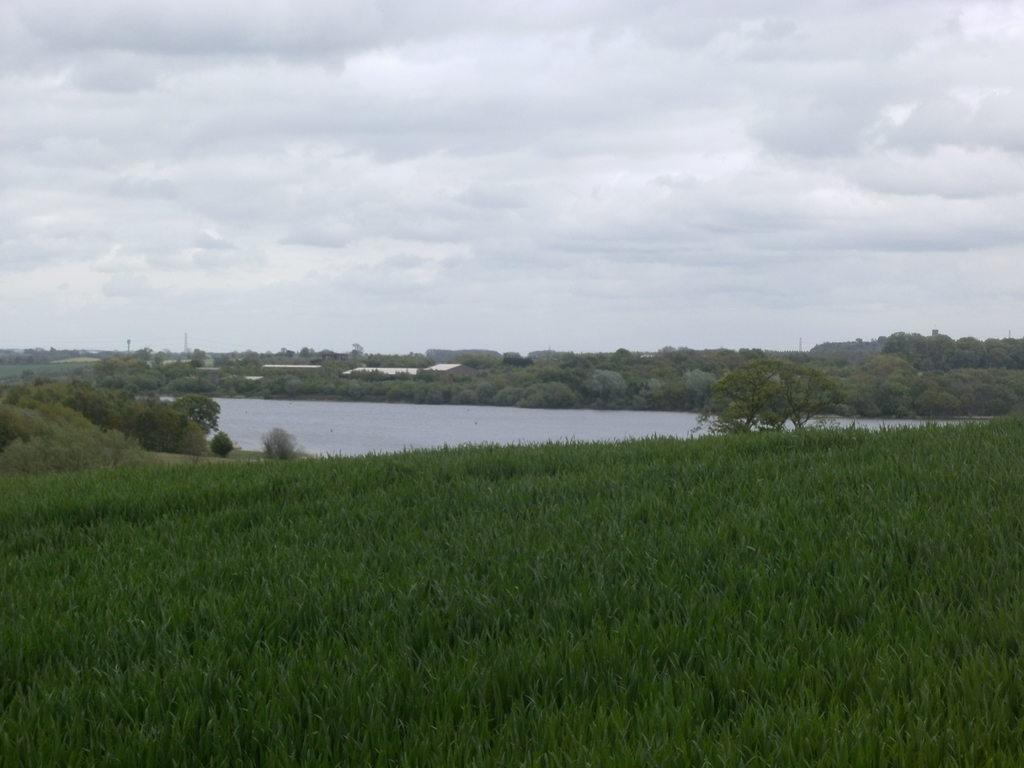What type of vegetation can be seen in the image? There is grass, plants, and trees visible in the image. What natural element is present in the image besides vegetation? There is water visible in the image. What is the condition of the sky in the image? The sky is cloudy in the image. What type of invention is being demonstrated in the image? There is no invention being demonstrated in the image; it features natural elements such as grass, plants, trees, water, and a cloudy sky. What type of flowers can be seen growing in the image? There is no mention of flowers in the image; it features grass, plants, trees, water, and a cloudy sky. 